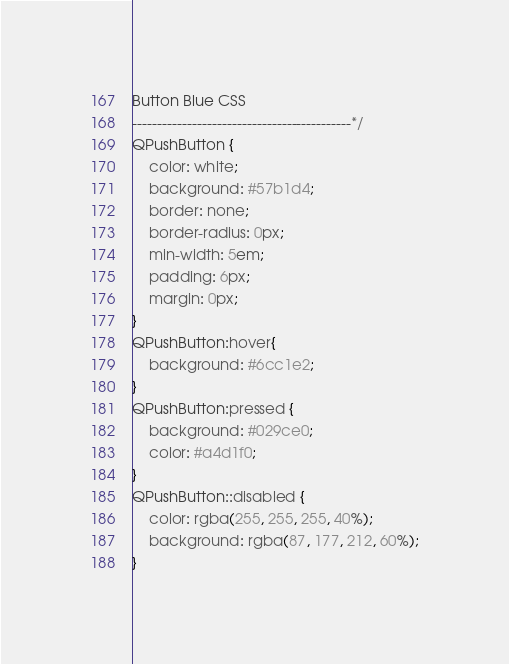Convert code to text. <code><loc_0><loc_0><loc_500><loc_500><_CSS_>Button Blue CSS
--------------------------------------------*/
QPushButton {
    color: white; 
    background: #57b1d4;
    border: none;
    border-radius: 0px;
    min-width: 5em;
    padding: 6px;
    margin: 0px;
}
QPushButton:hover{
    background: #6cc1e2;
}
QPushButton:pressed {
    background: #029ce0;
    color: #a4d1f0;
}
QPushButton::disabled {
    color: rgba(255, 255, 255, 40%);
    background: rgba(87, 177, 212, 60%);
}
</code> 